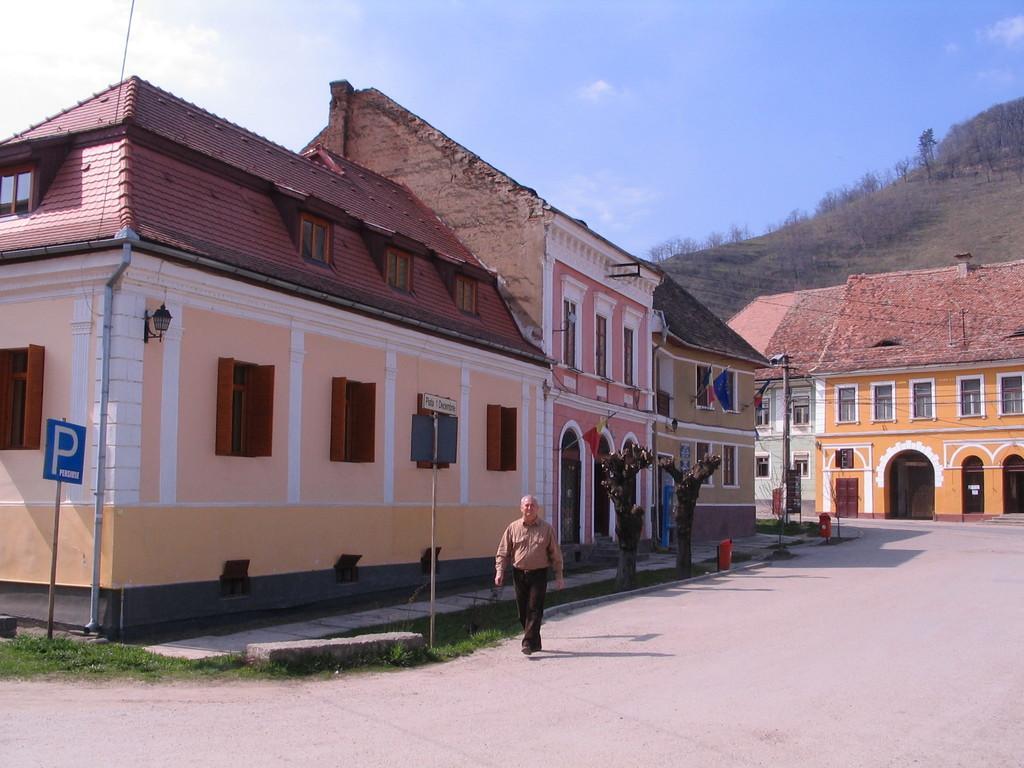How would you summarize this image in a sentence or two? In this image, there is a man walking on the road, there are some homes, at the left side there is a blue color parking sign board, at the background there is a mountain and there is a blue color sky at the top. 